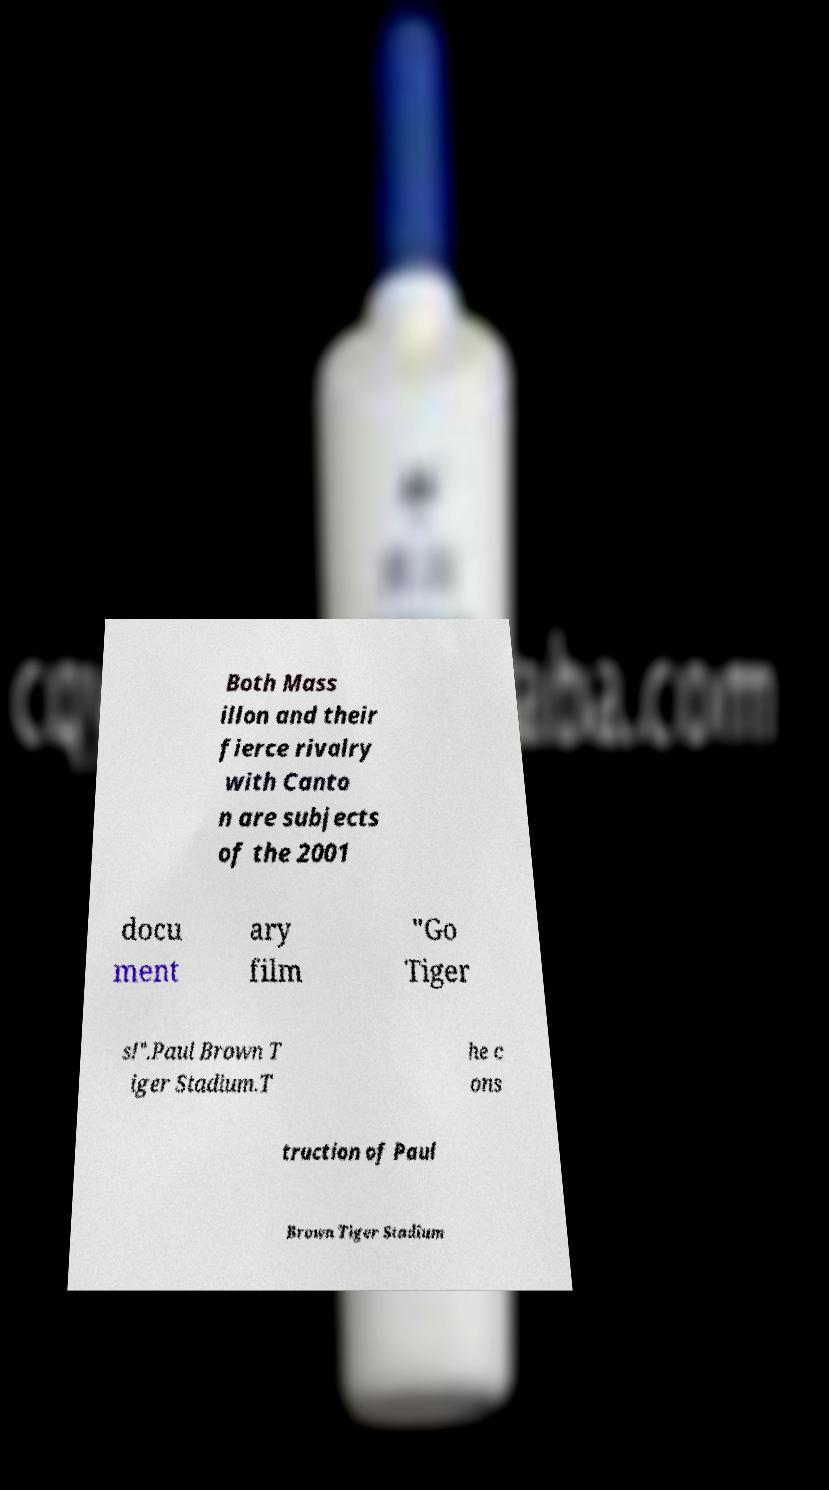There's text embedded in this image that I need extracted. Can you transcribe it verbatim? Both Mass illon and their fierce rivalry with Canto n are subjects of the 2001 docu ment ary film "Go Tiger s!".Paul Brown T iger Stadium.T he c ons truction of Paul Brown Tiger Stadium 